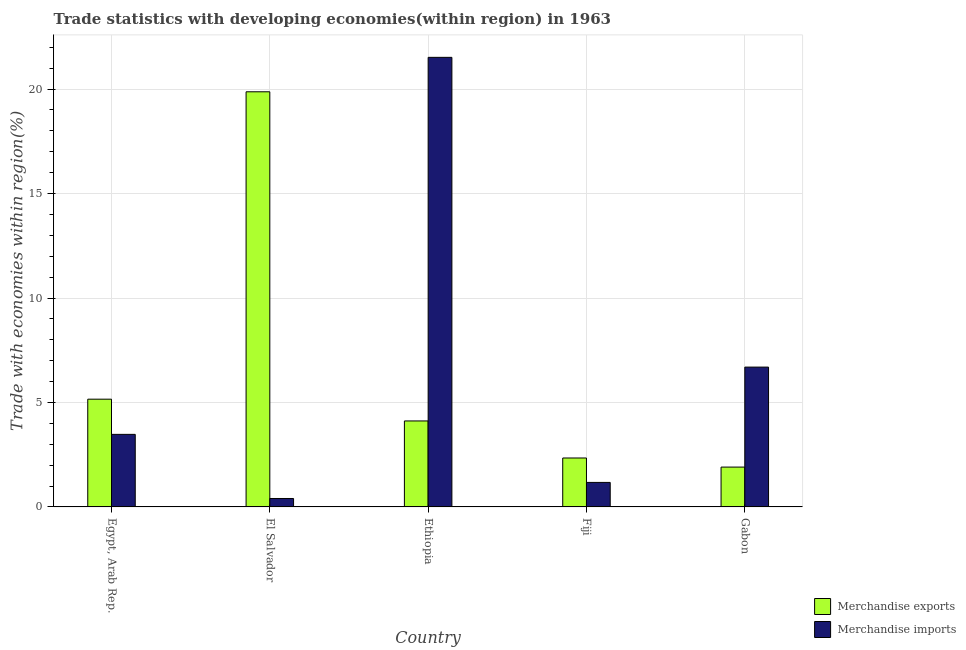Are the number of bars on each tick of the X-axis equal?
Offer a very short reply. Yes. How many bars are there on the 4th tick from the left?
Provide a succinct answer. 2. How many bars are there on the 3rd tick from the right?
Offer a very short reply. 2. What is the label of the 1st group of bars from the left?
Your response must be concise. Egypt, Arab Rep. What is the merchandise exports in Ethiopia?
Offer a very short reply. 4.12. Across all countries, what is the maximum merchandise exports?
Your answer should be very brief. 19.87. Across all countries, what is the minimum merchandise imports?
Offer a terse response. 0.4. In which country was the merchandise exports maximum?
Make the answer very short. El Salvador. In which country was the merchandise exports minimum?
Your response must be concise. Gabon. What is the total merchandise exports in the graph?
Keep it short and to the point. 33.39. What is the difference between the merchandise imports in Ethiopia and that in Fiji?
Offer a very short reply. 20.34. What is the difference between the merchandise imports in El Salvador and the merchandise exports in Ethiopia?
Your response must be concise. -3.71. What is the average merchandise imports per country?
Provide a short and direct response. 6.65. What is the difference between the merchandise imports and merchandise exports in El Salvador?
Provide a short and direct response. -19.47. In how many countries, is the merchandise imports greater than 16 %?
Offer a terse response. 1. What is the ratio of the merchandise imports in Ethiopia to that in Fiji?
Your response must be concise. 18.34. Is the difference between the merchandise exports in Ethiopia and Gabon greater than the difference between the merchandise imports in Ethiopia and Gabon?
Provide a short and direct response. No. What is the difference between the highest and the second highest merchandise exports?
Offer a very short reply. 14.71. What is the difference between the highest and the lowest merchandise exports?
Provide a succinct answer. 17.96. Is the sum of the merchandise imports in El Salvador and Ethiopia greater than the maximum merchandise exports across all countries?
Make the answer very short. Yes. What does the 2nd bar from the left in Egypt, Arab Rep. represents?
Give a very brief answer. Merchandise imports. What does the 1st bar from the right in Fiji represents?
Your answer should be compact. Merchandise imports. What is the difference between two consecutive major ticks on the Y-axis?
Offer a very short reply. 5. Does the graph contain any zero values?
Your answer should be very brief. No. Does the graph contain grids?
Your answer should be compact. Yes. How many legend labels are there?
Offer a very short reply. 2. What is the title of the graph?
Make the answer very short. Trade statistics with developing economies(within region) in 1963. What is the label or title of the X-axis?
Give a very brief answer. Country. What is the label or title of the Y-axis?
Ensure brevity in your answer.  Trade with economies within region(%). What is the Trade with economies within region(%) in Merchandise exports in Egypt, Arab Rep.?
Offer a terse response. 5.16. What is the Trade with economies within region(%) of Merchandise imports in Egypt, Arab Rep.?
Your answer should be very brief. 3.47. What is the Trade with economies within region(%) in Merchandise exports in El Salvador?
Keep it short and to the point. 19.87. What is the Trade with economies within region(%) in Merchandise imports in El Salvador?
Offer a terse response. 0.4. What is the Trade with economies within region(%) in Merchandise exports in Ethiopia?
Your answer should be very brief. 4.12. What is the Trade with economies within region(%) of Merchandise imports in Ethiopia?
Your answer should be compact. 21.52. What is the Trade with economies within region(%) of Merchandise exports in Fiji?
Ensure brevity in your answer.  2.34. What is the Trade with economies within region(%) of Merchandise imports in Fiji?
Make the answer very short. 1.17. What is the Trade with economies within region(%) of Merchandise exports in Gabon?
Provide a succinct answer. 1.91. What is the Trade with economies within region(%) of Merchandise imports in Gabon?
Your answer should be compact. 6.69. Across all countries, what is the maximum Trade with economies within region(%) in Merchandise exports?
Keep it short and to the point. 19.87. Across all countries, what is the maximum Trade with economies within region(%) of Merchandise imports?
Ensure brevity in your answer.  21.52. Across all countries, what is the minimum Trade with economies within region(%) in Merchandise exports?
Give a very brief answer. 1.91. Across all countries, what is the minimum Trade with economies within region(%) of Merchandise imports?
Provide a short and direct response. 0.4. What is the total Trade with economies within region(%) of Merchandise exports in the graph?
Ensure brevity in your answer.  33.39. What is the total Trade with economies within region(%) in Merchandise imports in the graph?
Your answer should be very brief. 33.26. What is the difference between the Trade with economies within region(%) in Merchandise exports in Egypt, Arab Rep. and that in El Salvador?
Your response must be concise. -14.71. What is the difference between the Trade with economies within region(%) in Merchandise imports in Egypt, Arab Rep. and that in El Salvador?
Offer a terse response. 3.07. What is the difference between the Trade with economies within region(%) in Merchandise exports in Egypt, Arab Rep. and that in Ethiopia?
Your response must be concise. 1.04. What is the difference between the Trade with economies within region(%) of Merchandise imports in Egypt, Arab Rep. and that in Ethiopia?
Offer a terse response. -18.05. What is the difference between the Trade with economies within region(%) in Merchandise exports in Egypt, Arab Rep. and that in Fiji?
Provide a short and direct response. 2.81. What is the difference between the Trade with economies within region(%) in Merchandise imports in Egypt, Arab Rep. and that in Fiji?
Make the answer very short. 2.3. What is the difference between the Trade with economies within region(%) in Merchandise exports in Egypt, Arab Rep. and that in Gabon?
Offer a very short reply. 3.25. What is the difference between the Trade with economies within region(%) in Merchandise imports in Egypt, Arab Rep. and that in Gabon?
Ensure brevity in your answer.  -3.22. What is the difference between the Trade with economies within region(%) in Merchandise exports in El Salvador and that in Ethiopia?
Make the answer very short. 15.75. What is the difference between the Trade with economies within region(%) in Merchandise imports in El Salvador and that in Ethiopia?
Ensure brevity in your answer.  -21.11. What is the difference between the Trade with economies within region(%) in Merchandise exports in El Salvador and that in Fiji?
Provide a succinct answer. 17.53. What is the difference between the Trade with economies within region(%) of Merchandise imports in El Salvador and that in Fiji?
Offer a terse response. -0.77. What is the difference between the Trade with economies within region(%) in Merchandise exports in El Salvador and that in Gabon?
Make the answer very short. 17.96. What is the difference between the Trade with economies within region(%) in Merchandise imports in El Salvador and that in Gabon?
Offer a very short reply. -6.29. What is the difference between the Trade with economies within region(%) in Merchandise exports in Ethiopia and that in Fiji?
Offer a very short reply. 1.77. What is the difference between the Trade with economies within region(%) of Merchandise imports in Ethiopia and that in Fiji?
Make the answer very short. 20.34. What is the difference between the Trade with economies within region(%) of Merchandise exports in Ethiopia and that in Gabon?
Offer a very short reply. 2.21. What is the difference between the Trade with economies within region(%) of Merchandise imports in Ethiopia and that in Gabon?
Offer a very short reply. 14.83. What is the difference between the Trade with economies within region(%) in Merchandise exports in Fiji and that in Gabon?
Your answer should be compact. 0.43. What is the difference between the Trade with economies within region(%) in Merchandise imports in Fiji and that in Gabon?
Give a very brief answer. -5.52. What is the difference between the Trade with economies within region(%) in Merchandise exports in Egypt, Arab Rep. and the Trade with economies within region(%) in Merchandise imports in El Salvador?
Your response must be concise. 4.75. What is the difference between the Trade with economies within region(%) of Merchandise exports in Egypt, Arab Rep. and the Trade with economies within region(%) of Merchandise imports in Ethiopia?
Keep it short and to the point. -16.36. What is the difference between the Trade with economies within region(%) in Merchandise exports in Egypt, Arab Rep. and the Trade with economies within region(%) in Merchandise imports in Fiji?
Provide a succinct answer. 3.98. What is the difference between the Trade with economies within region(%) of Merchandise exports in Egypt, Arab Rep. and the Trade with economies within region(%) of Merchandise imports in Gabon?
Provide a short and direct response. -1.54. What is the difference between the Trade with economies within region(%) in Merchandise exports in El Salvador and the Trade with economies within region(%) in Merchandise imports in Ethiopia?
Your answer should be very brief. -1.65. What is the difference between the Trade with economies within region(%) of Merchandise exports in El Salvador and the Trade with economies within region(%) of Merchandise imports in Fiji?
Your response must be concise. 18.7. What is the difference between the Trade with economies within region(%) of Merchandise exports in El Salvador and the Trade with economies within region(%) of Merchandise imports in Gabon?
Keep it short and to the point. 13.18. What is the difference between the Trade with economies within region(%) of Merchandise exports in Ethiopia and the Trade with economies within region(%) of Merchandise imports in Fiji?
Make the answer very short. 2.94. What is the difference between the Trade with economies within region(%) in Merchandise exports in Ethiopia and the Trade with economies within region(%) in Merchandise imports in Gabon?
Ensure brevity in your answer.  -2.58. What is the difference between the Trade with economies within region(%) of Merchandise exports in Fiji and the Trade with economies within region(%) of Merchandise imports in Gabon?
Give a very brief answer. -4.35. What is the average Trade with economies within region(%) of Merchandise exports per country?
Give a very brief answer. 6.68. What is the average Trade with economies within region(%) in Merchandise imports per country?
Your answer should be compact. 6.65. What is the difference between the Trade with economies within region(%) in Merchandise exports and Trade with economies within region(%) in Merchandise imports in Egypt, Arab Rep.?
Your response must be concise. 1.68. What is the difference between the Trade with economies within region(%) of Merchandise exports and Trade with economies within region(%) of Merchandise imports in El Salvador?
Offer a terse response. 19.47. What is the difference between the Trade with economies within region(%) of Merchandise exports and Trade with economies within region(%) of Merchandise imports in Ethiopia?
Your answer should be very brief. -17.4. What is the difference between the Trade with economies within region(%) in Merchandise exports and Trade with economies within region(%) in Merchandise imports in Fiji?
Ensure brevity in your answer.  1.17. What is the difference between the Trade with economies within region(%) in Merchandise exports and Trade with economies within region(%) in Merchandise imports in Gabon?
Give a very brief answer. -4.79. What is the ratio of the Trade with economies within region(%) of Merchandise exports in Egypt, Arab Rep. to that in El Salvador?
Provide a short and direct response. 0.26. What is the ratio of the Trade with economies within region(%) of Merchandise imports in Egypt, Arab Rep. to that in El Salvador?
Offer a very short reply. 8.6. What is the ratio of the Trade with economies within region(%) in Merchandise exports in Egypt, Arab Rep. to that in Ethiopia?
Ensure brevity in your answer.  1.25. What is the ratio of the Trade with economies within region(%) of Merchandise imports in Egypt, Arab Rep. to that in Ethiopia?
Give a very brief answer. 0.16. What is the ratio of the Trade with economies within region(%) in Merchandise exports in Egypt, Arab Rep. to that in Fiji?
Your answer should be very brief. 2.2. What is the ratio of the Trade with economies within region(%) of Merchandise imports in Egypt, Arab Rep. to that in Fiji?
Keep it short and to the point. 2.96. What is the ratio of the Trade with economies within region(%) of Merchandise exports in Egypt, Arab Rep. to that in Gabon?
Keep it short and to the point. 2.7. What is the ratio of the Trade with economies within region(%) of Merchandise imports in Egypt, Arab Rep. to that in Gabon?
Provide a short and direct response. 0.52. What is the ratio of the Trade with economies within region(%) in Merchandise exports in El Salvador to that in Ethiopia?
Offer a terse response. 4.83. What is the ratio of the Trade with economies within region(%) in Merchandise imports in El Salvador to that in Ethiopia?
Provide a short and direct response. 0.02. What is the ratio of the Trade with economies within region(%) in Merchandise exports in El Salvador to that in Fiji?
Offer a very short reply. 8.48. What is the ratio of the Trade with economies within region(%) of Merchandise imports in El Salvador to that in Fiji?
Offer a terse response. 0.34. What is the ratio of the Trade with economies within region(%) of Merchandise exports in El Salvador to that in Gabon?
Offer a terse response. 10.42. What is the ratio of the Trade with economies within region(%) in Merchandise imports in El Salvador to that in Gabon?
Keep it short and to the point. 0.06. What is the ratio of the Trade with economies within region(%) of Merchandise exports in Ethiopia to that in Fiji?
Your answer should be compact. 1.76. What is the ratio of the Trade with economies within region(%) of Merchandise imports in Ethiopia to that in Fiji?
Your answer should be very brief. 18.34. What is the ratio of the Trade with economies within region(%) of Merchandise exports in Ethiopia to that in Gabon?
Offer a terse response. 2.16. What is the ratio of the Trade with economies within region(%) of Merchandise imports in Ethiopia to that in Gabon?
Your answer should be compact. 3.22. What is the ratio of the Trade with economies within region(%) of Merchandise exports in Fiji to that in Gabon?
Offer a very short reply. 1.23. What is the ratio of the Trade with economies within region(%) of Merchandise imports in Fiji to that in Gabon?
Keep it short and to the point. 0.18. What is the difference between the highest and the second highest Trade with economies within region(%) in Merchandise exports?
Make the answer very short. 14.71. What is the difference between the highest and the second highest Trade with economies within region(%) of Merchandise imports?
Your response must be concise. 14.83. What is the difference between the highest and the lowest Trade with economies within region(%) in Merchandise exports?
Ensure brevity in your answer.  17.96. What is the difference between the highest and the lowest Trade with economies within region(%) of Merchandise imports?
Offer a very short reply. 21.11. 